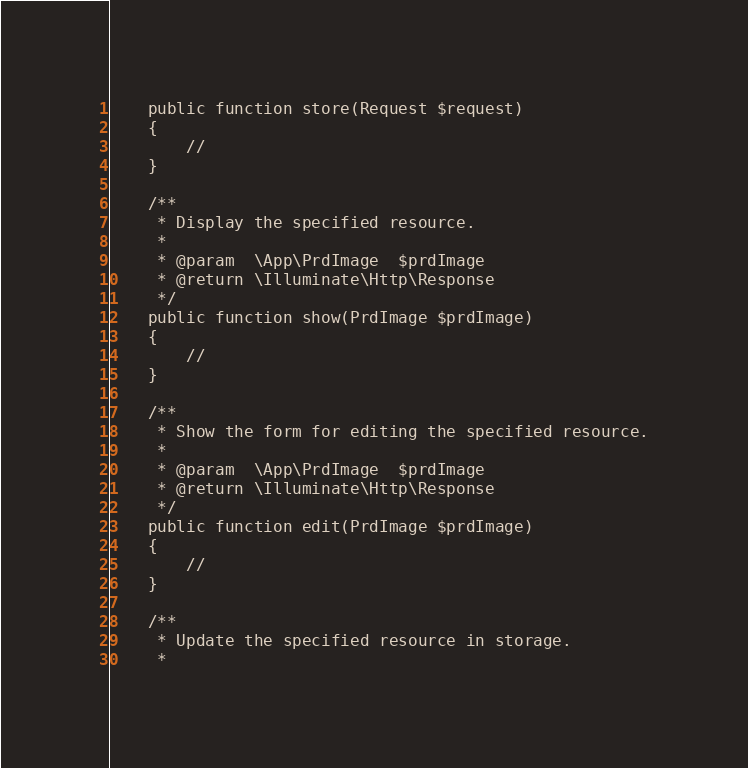<code> <loc_0><loc_0><loc_500><loc_500><_PHP_>    public function store(Request $request)
    {
        //
    }

    /**
     * Display the specified resource.
     *
     * @param  \App\PrdImage  $prdImage
     * @return \Illuminate\Http\Response
     */
    public function show(PrdImage $prdImage)
    {
        //
    }

    /**
     * Show the form for editing the specified resource.
     *
     * @param  \App\PrdImage  $prdImage
     * @return \Illuminate\Http\Response
     */
    public function edit(PrdImage $prdImage)
    {
        //
    }

    /**
     * Update the specified resource in storage.
     *</code> 